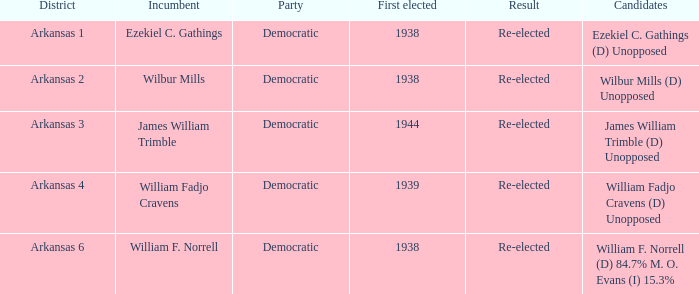How many districts had William F. Norrell as the incumbent? 1.0. 